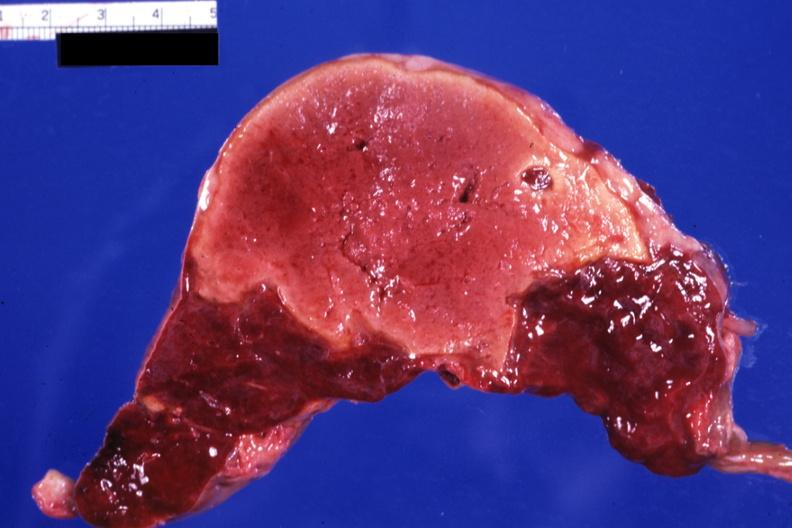what is present?
Answer the question using a single word or phrase. Infarct 